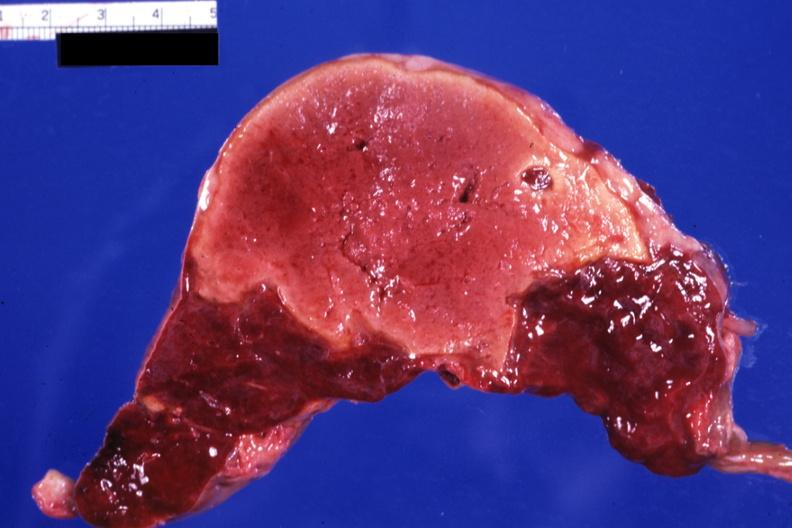what is present?
Answer the question using a single word or phrase. Infarct 